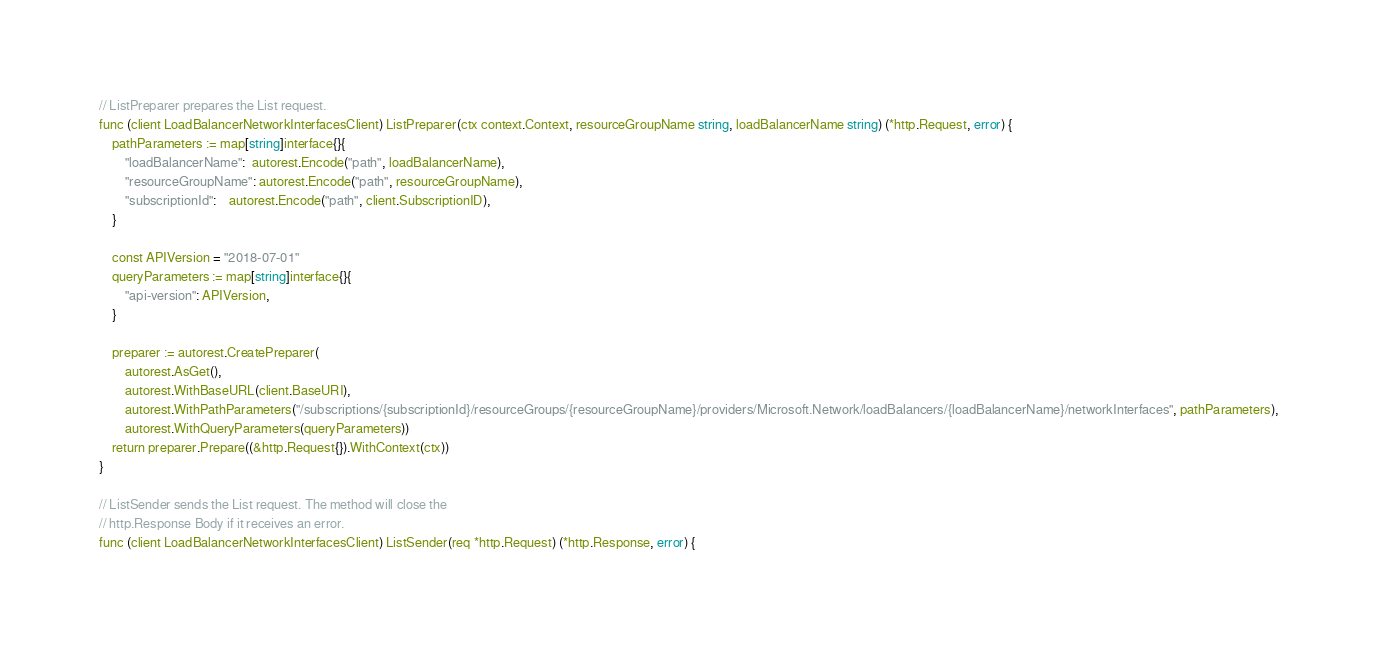<code> <loc_0><loc_0><loc_500><loc_500><_Go_>
// ListPreparer prepares the List request.
func (client LoadBalancerNetworkInterfacesClient) ListPreparer(ctx context.Context, resourceGroupName string, loadBalancerName string) (*http.Request, error) {
	pathParameters := map[string]interface{}{
		"loadBalancerName":  autorest.Encode("path", loadBalancerName),
		"resourceGroupName": autorest.Encode("path", resourceGroupName),
		"subscriptionId":    autorest.Encode("path", client.SubscriptionID),
	}

	const APIVersion = "2018-07-01"
	queryParameters := map[string]interface{}{
		"api-version": APIVersion,
	}

	preparer := autorest.CreatePreparer(
		autorest.AsGet(),
		autorest.WithBaseURL(client.BaseURI),
		autorest.WithPathParameters("/subscriptions/{subscriptionId}/resourceGroups/{resourceGroupName}/providers/Microsoft.Network/loadBalancers/{loadBalancerName}/networkInterfaces", pathParameters),
		autorest.WithQueryParameters(queryParameters))
	return preparer.Prepare((&http.Request{}).WithContext(ctx))
}

// ListSender sends the List request. The method will close the
// http.Response Body if it receives an error.
func (client LoadBalancerNetworkInterfacesClient) ListSender(req *http.Request) (*http.Response, error) {</code> 